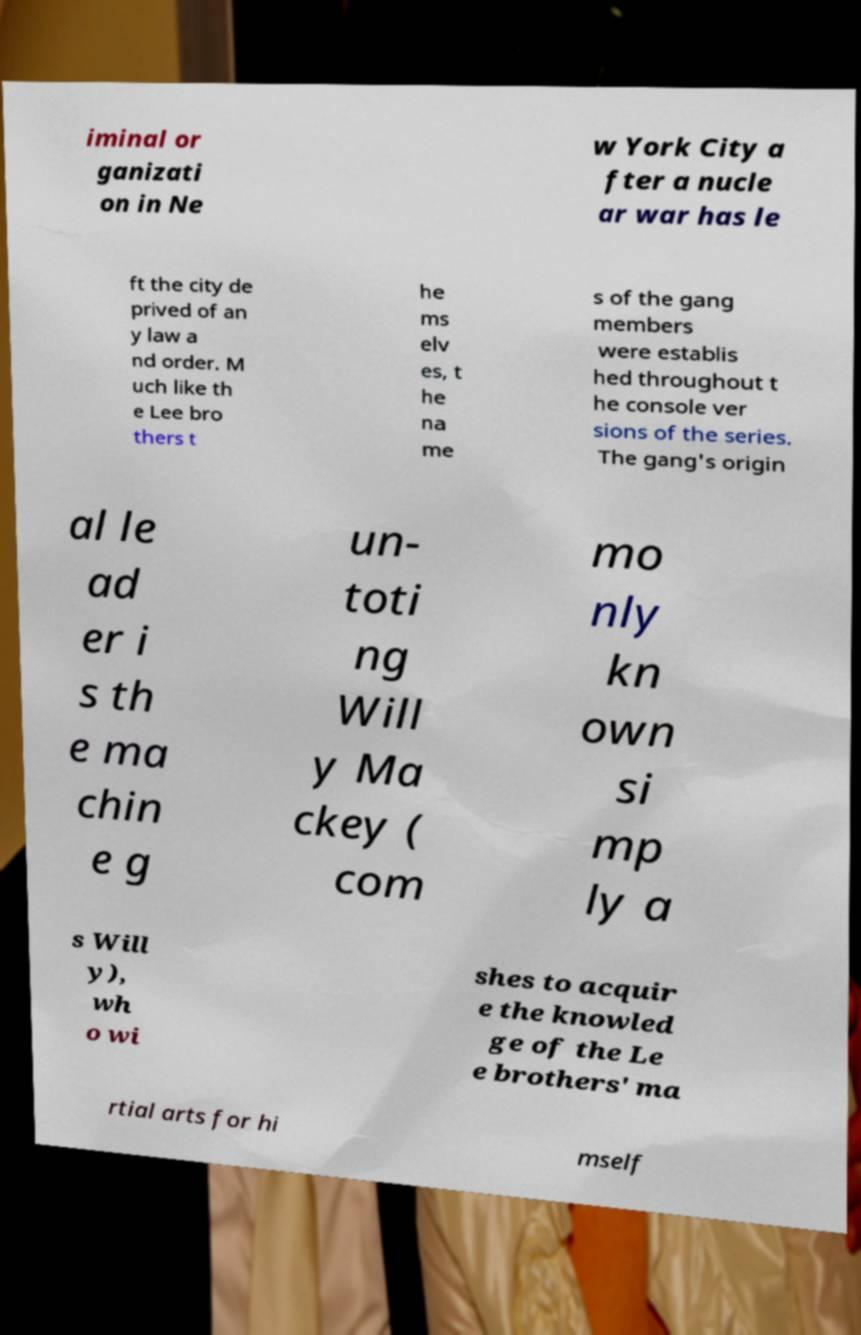Could you extract and type out the text from this image? iminal or ganizati on in Ne w York City a fter a nucle ar war has le ft the city de prived of an y law a nd order. M uch like th e Lee bro thers t he ms elv es, t he na me s of the gang members were establis hed throughout t he console ver sions of the series. The gang's origin al le ad er i s th e ma chin e g un- toti ng Will y Ma ckey ( com mo nly kn own si mp ly a s Will y), wh o wi shes to acquir e the knowled ge of the Le e brothers' ma rtial arts for hi mself 